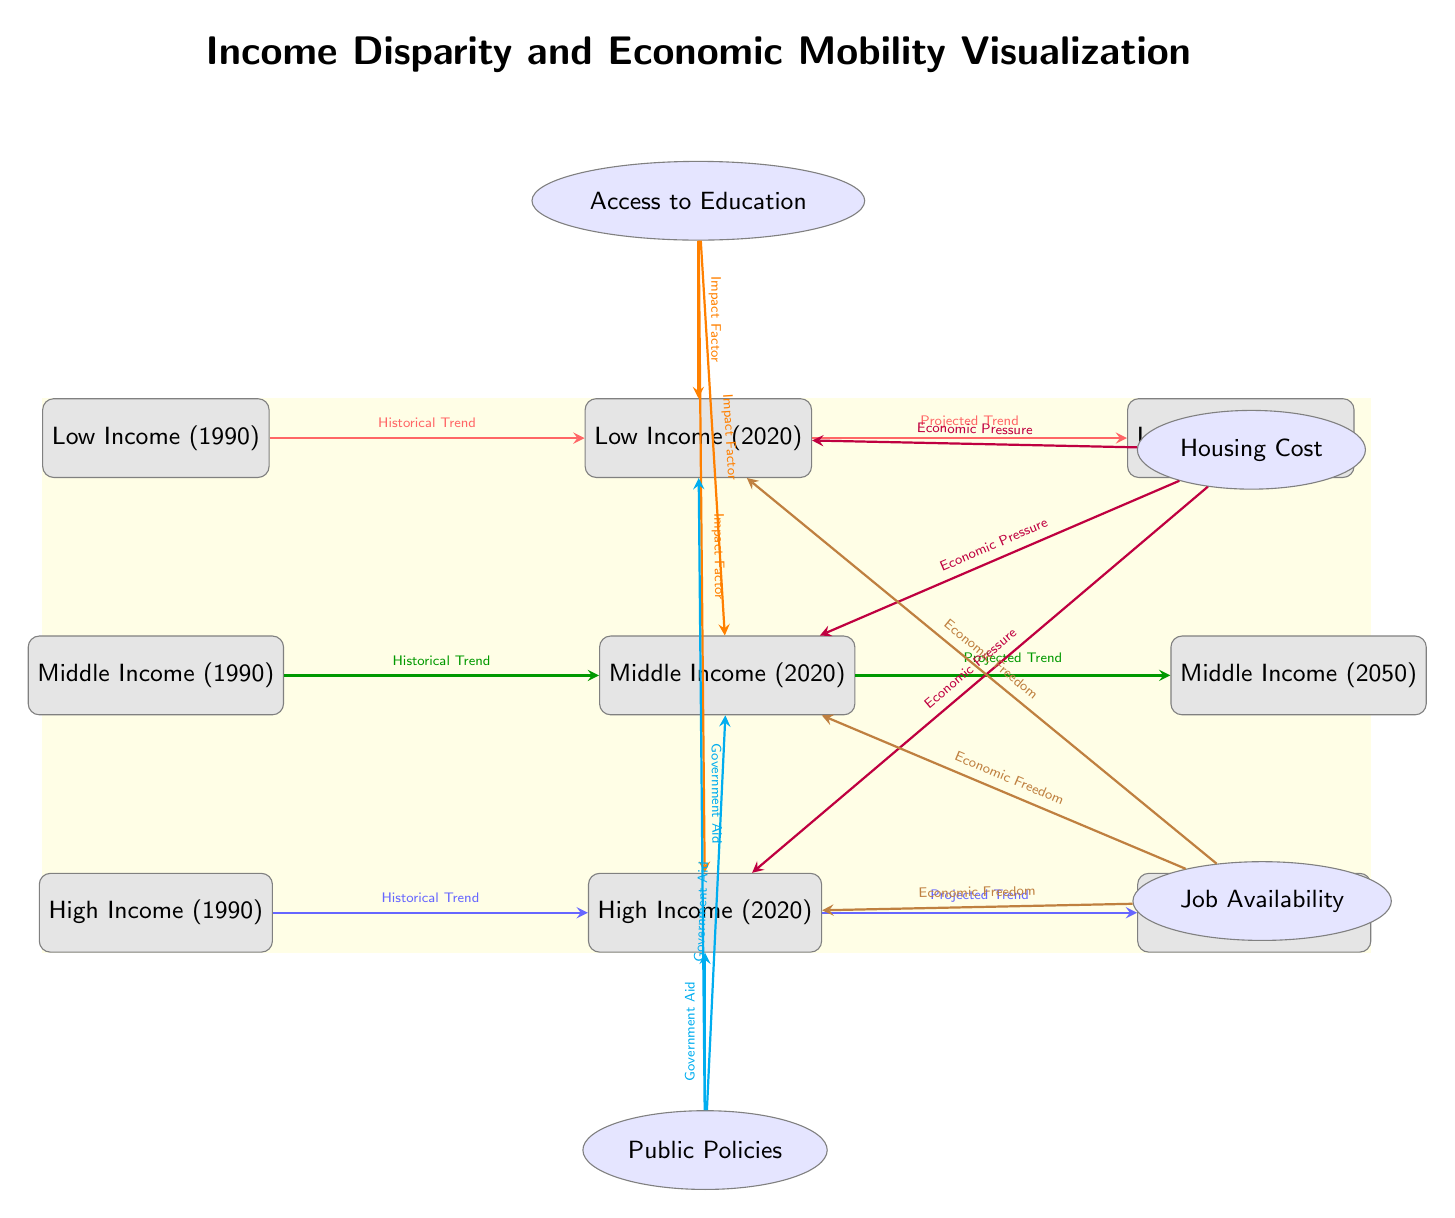What is the income group represented in 1990 for low income? The diagram indicates that the node labeled "Low Income (1990)" represents the low income group in the year 1990, directly identified in the first node of the first row.
Answer: Low Income (1990) What factors impact low income in 2020 as shown in the diagram? The diagram shows that the factors impacting "Low Income (2020)" are "Access to Education," "Housing Cost," "Job Availability," and "Public Policies," all of which have directed arrows pointing towards it.
Answer: Access to Education, Housing Cost, Job Availability, Public Policies How many nodes represent the middle income group? By counting the nodes in the middle row of the diagram, there are three nodes that represent the middle income group across different years: "Middle Income (1990)," "Middle Income (2020)," and "Middle Income (2050)."
Answer: 3 What is the historical trend direction from middle income in 1990 to 2020? The arrow between "Middle Income (1990)" and "Middle Income (2020)" depicts a historical trend, indicated by the thick green arrow labeled "Historical Trend," representing the movement from 1990 to 2020.
Answer: Historical Trend What type of arrow relates Government Aid to high income in 2020? The arrow leading from the "Public Policies" factor to "High Income (2020)" indicates a relationship characterized as "Government Aid," illustrated with a cyan arrow labeled accordingly.
Answer: Government Aid What are the projected trends for high income from 2020 to 2050? The arrow connecting "High Income (2020)" to "High Income (2050)" is labeled "Projected Trend," suggesting an expected future trajectory of data regarding high income over the years.
Answer: Projected Trend Which economic pressure factor is related to middle income in 2020? The arrow from "Housing Cost" pointing to "Middle Income (2020)" indicates that this factor is characterized as "Economic Pressure," demonstrating the influence housing costs have in that year.
Answer: Economic Pressure What historical trend exists for low income from 1990 to 2050? The diagram shows two arrows: one historical trend from "Low Income (1990)" to "Low Income (2020)" and another projected trend from "Low Income (2020)" to "Low Income (2050)," creating an overarching historical context for the changes over time.
Answer: Historical Trend, Projected Trend 